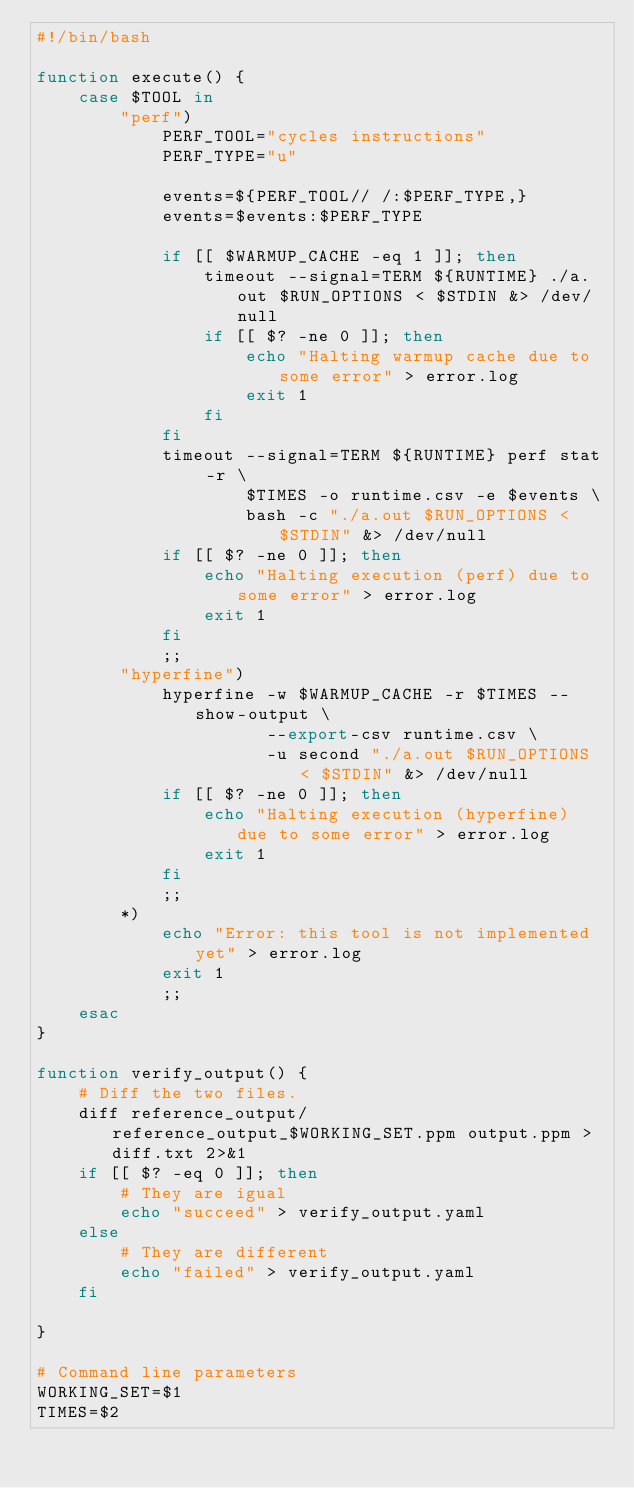<code> <loc_0><loc_0><loc_500><loc_500><_Bash_>#!/bin/bash

function execute() {
    case $TOOL in
        "perf")
            PERF_TOOL="cycles instructions"
            PERF_TYPE="u"

            events=${PERF_TOOL// /:$PERF_TYPE,}
            events=$events:$PERF_TYPE

            if [[ $WARMUP_CACHE -eq 1 ]]; then
                timeout --signal=TERM ${RUNTIME} ./a.out $RUN_OPTIONS < $STDIN &> /dev/null
                if [[ $? -ne 0 ]]; then
                    echo "Halting warmup cache due to some error" > error.log
                    exit 1
                fi
            fi
            timeout --signal=TERM ${RUNTIME} perf stat -r \
                    $TIMES -o runtime.csv -e $events \
                    bash -c "./a.out $RUN_OPTIONS < $STDIN" &> /dev/null
            if [[ $? -ne 0 ]]; then
                echo "Halting execution (perf) due to some error" > error.log
                exit 1
            fi
            ;;
        "hyperfine")
            hyperfine -w $WARMUP_CACHE -r $TIMES --show-output \
                      --export-csv runtime.csv \
                      -u second "./a.out $RUN_OPTIONS < $STDIN" &> /dev/null
            if [[ $? -ne 0 ]]; then
                echo "Halting execution (hyperfine) due to some error" > error.log
                exit 1
            fi
            ;;
        *)
            echo "Error: this tool is not implemented yet" > error.log
            exit 1
            ;;
    esac
}

function verify_output() {
    # Diff the two files.
    diff reference_output/reference_output_$WORKING_SET.ppm output.ppm > diff.txt 2>&1
    if [[ $? -eq 0 ]]; then
        # They are igual
        echo "succeed" > verify_output.yaml
    else
        # They are different
        echo "failed" > verify_output.yaml
    fi

}

# Command line parameters
WORKING_SET=$1
TIMES=$2</code> 